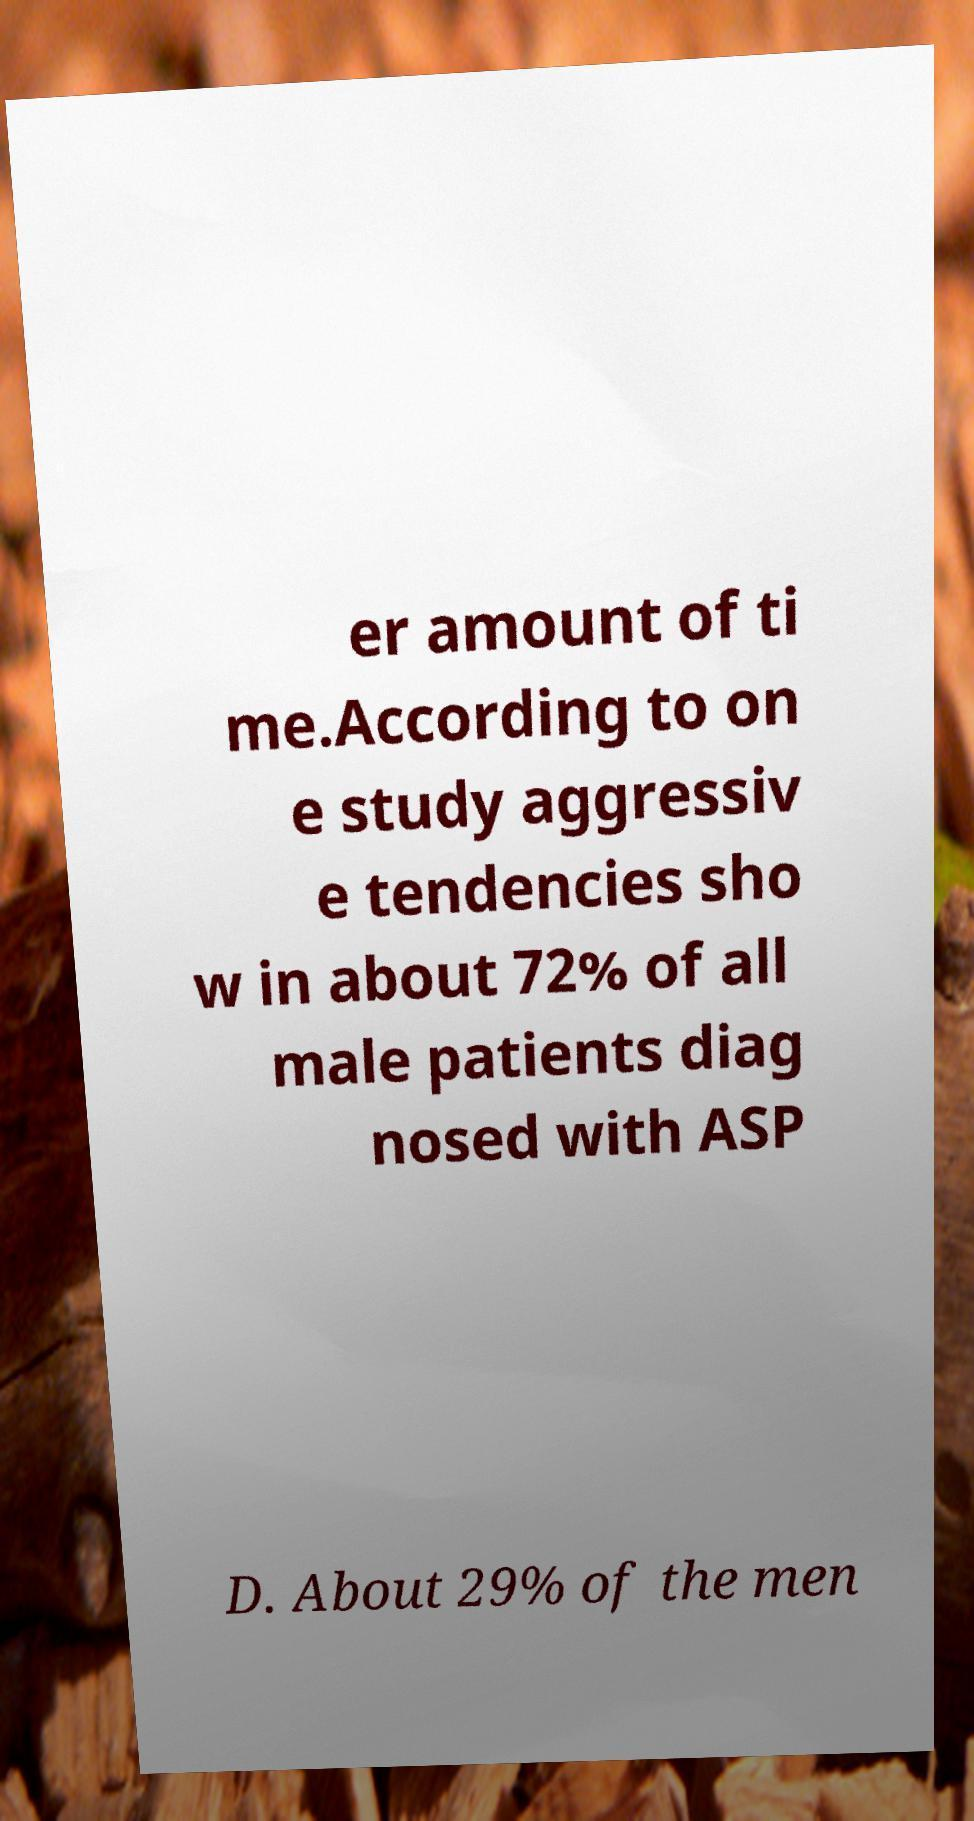For documentation purposes, I need the text within this image transcribed. Could you provide that? er amount of ti me.According to on e study aggressiv e tendencies sho w in about 72% of all male patients diag nosed with ASP D. About 29% of the men 